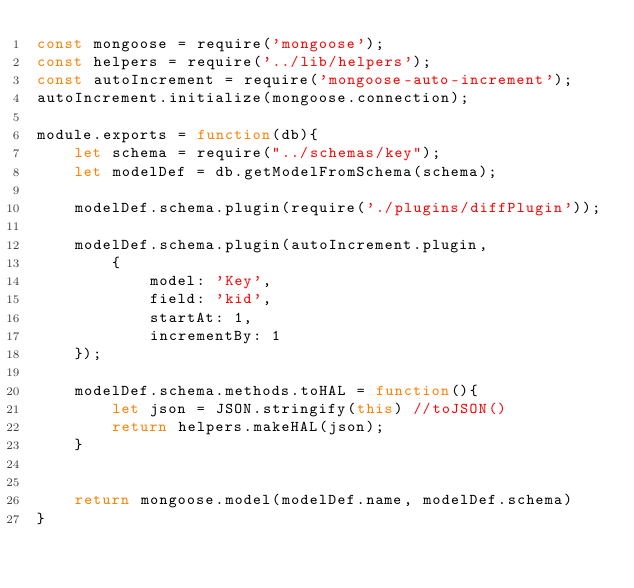Convert code to text. <code><loc_0><loc_0><loc_500><loc_500><_JavaScript_>const mongoose = require('mongoose');
const helpers = require('../lib/helpers');
const autoIncrement = require('mongoose-auto-increment');
autoIncrement.initialize(mongoose.connection);

module.exports = function(db){
    let schema = require("../schemas/key");  
    let modelDef = db.getModelFromSchema(schema);

    modelDef.schema.plugin(require('./plugins/diffPlugin'));

    modelDef.schema.plugin(autoIncrement.plugin, 
        { 
            model: 'Key', 
            field: 'kid',
            startAt: 1,
            incrementBy: 1
    });

    modelDef.schema.methods.toHAL = function(){                
        let json = JSON.stringify(this) //toJSON()                
        return helpers.makeHAL(json);        
    }


    return mongoose.model(modelDef.name, modelDef.schema)
}</code> 